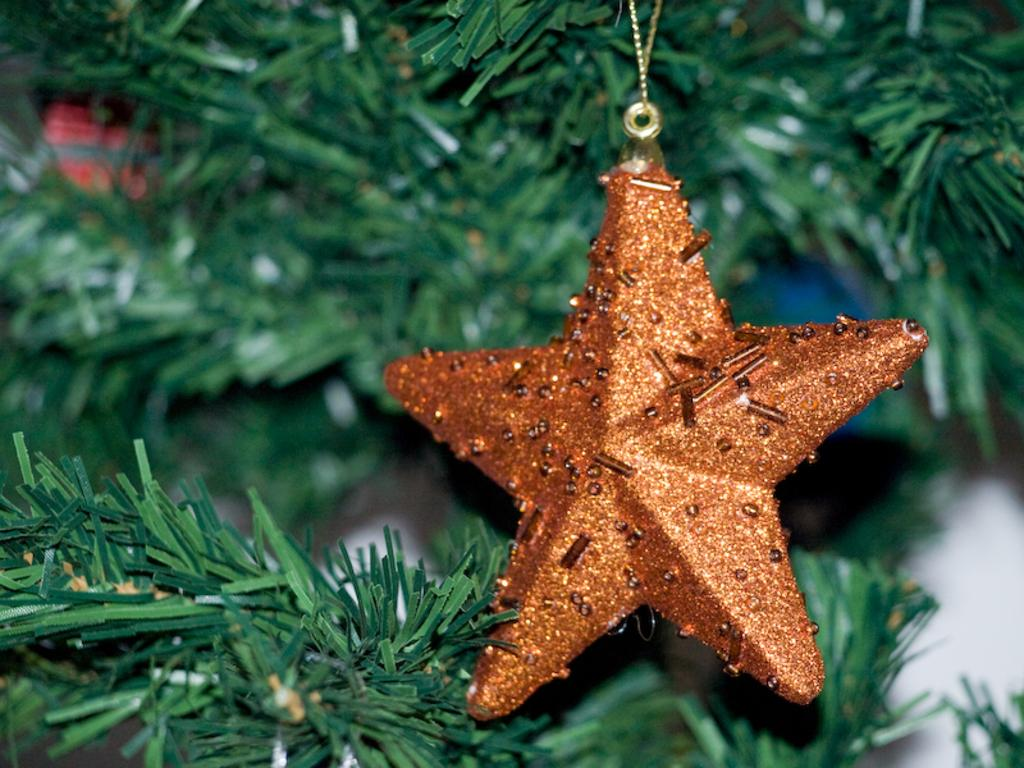What is the main object in the image? There is a Christmas tree in the image. What decoration is hanging from the Christmas tree? The Christmas tree has a little star hanging from its stem. What theory does the queen propose in the image? There is no queen or theory present in the image; it only features a Christmas tree with a little star. 